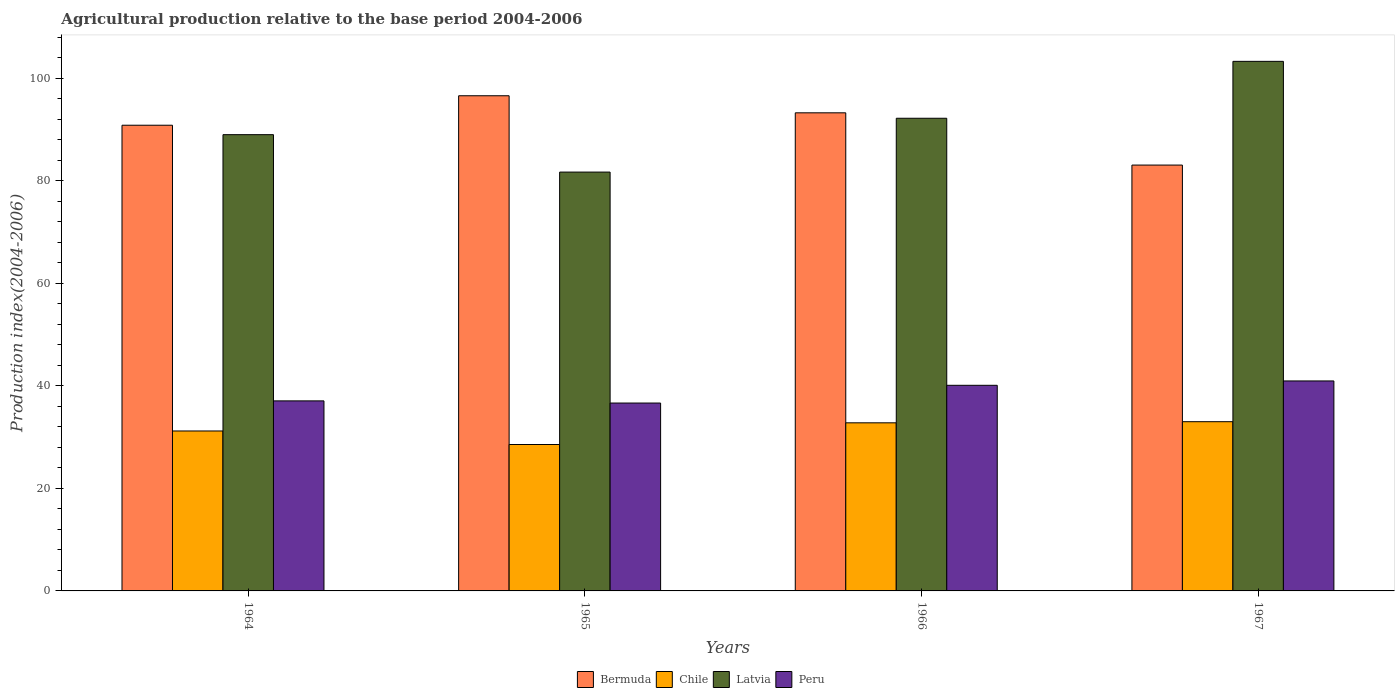How many different coloured bars are there?
Offer a very short reply. 4. How many groups of bars are there?
Make the answer very short. 4. Are the number of bars on each tick of the X-axis equal?
Provide a short and direct response. Yes. How many bars are there on the 1st tick from the right?
Keep it short and to the point. 4. What is the label of the 3rd group of bars from the left?
Make the answer very short. 1966. In how many cases, is the number of bars for a given year not equal to the number of legend labels?
Make the answer very short. 0. What is the agricultural production index in Chile in 1965?
Offer a very short reply. 28.56. Across all years, what is the maximum agricultural production index in Latvia?
Offer a terse response. 103.3. Across all years, what is the minimum agricultural production index in Chile?
Offer a very short reply. 28.56. In which year was the agricultural production index in Chile maximum?
Offer a terse response. 1967. In which year was the agricultural production index in Bermuda minimum?
Keep it short and to the point. 1967. What is the total agricultural production index in Bermuda in the graph?
Offer a very short reply. 363.76. What is the difference between the agricultural production index in Peru in 1965 and that in 1966?
Give a very brief answer. -3.46. What is the difference between the agricultural production index in Bermuda in 1964 and the agricultural production index in Latvia in 1967?
Provide a succinct answer. -12.46. What is the average agricultural production index in Chile per year?
Give a very brief answer. 31.39. In the year 1966, what is the difference between the agricultural production index in Chile and agricultural production index in Latvia?
Make the answer very short. -59.41. What is the ratio of the agricultural production index in Peru in 1964 to that in 1967?
Your answer should be compact. 0.91. What is the difference between the highest and the second highest agricultural production index in Latvia?
Offer a very short reply. 11.1. What is the difference between the highest and the lowest agricultural production index in Bermuda?
Give a very brief answer. 13.52. Is it the case that in every year, the sum of the agricultural production index in Peru and agricultural production index in Latvia is greater than the sum of agricultural production index in Bermuda and agricultural production index in Chile?
Give a very brief answer. No. What does the 2nd bar from the left in 1964 represents?
Provide a short and direct response. Chile. Is it the case that in every year, the sum of the agricultural production index in Bermuda and agricultural production index in Peru is greater than the agricultural production index in Latvia?
Offer a very short reply. Yes. How many bars are there?
Your answer should be compact. 16. Are all the bars in the graph horizontal?
Keep it short and to the point. No. How many years are there in the graph?
Ensure brevity in your answer.  4. Does the graph contain any zero values?
Offer a terse response. No. Does the graph contain grids?
Provide a succinct answer. No. Where does the legend appear in the graph?
Keep it short and to the point. Bottom center. How many legend labels are there?
Provide a short and direct response. 4. How are the legend labels stacked?
Your answer should be very brief. Horizontal. What is the title of the graph?
Offer a terse response. Agricultural production relative to the base period 2004-2006. What is the label or title of the Y-axis?
Provide a succinct answer. Production index(2004-2006). What is the Production index(2004-2006) in Bermuda in 1964?
Your response must be concise. 90.84. What is the Production index(2004-2006) in Chile in 1964?
Offer a very short reply. 31.2. What is the Production index(2004-2006) of Latvia in 1964?
Ensure brevity in your answer.  89. What is the Production index(2004-2006) of Peru in 1964?
Offer a terse response. 37.07. What is the Production index(2004-2006) of Bermuda in 1965?
Provide a succinct answer. 96.59. What is the Production index(2004-2006) of Chile in 1965?
Give a very brief answer. 28.56. What is the Production index(2004-2006) in Latvia in 1965?
Ensure brevity in your answer.  81.7. What is the Production index(2004-2006) of Peru in 1965?
Provide a short and direct response. 36.65. What is the Production index(2004-2006) in Bermuda in 1966?
Your answer should be compact. 93.26. What is the Production index(2004-2006) in Chile in 1966?
Your answer should be very brief. 32.79. What is the Production index(2004-2006) of Latvia in 1966?
Your answer should be very brief. 92.2. What is the Production index(2004-2006) of Peru in 1966?
Make the answer very short. 40.11. What is the Production index(2004-2006) of Bermuda in 1967?
Ensure brevity in your answer.  83.07. What is the Production index(2004-2006) of Chile in 1967?
Ensure brevity in your answer.  33.01. What is the Production index(2004-2006) of Latvia in 1967?
Offer a very short reply. 103.3. What is the Production index(2004-2006) in Peru in 1967?
Your answer should be very brief. 40.96. Across all years, what is the maximum Production index(2004-2006) of Bermuda?
Ensure brevity in your answer.  96.59. Across all years, what is the maximum Production index(2004-2006) in Chile?
Give a very brief answer. 33.01. Across all years, what is the maximum Production index(2004-2006) of Latvia?
Your answer should be compact. 103.3. Across all years, what is the maximum Production index(2004-2006) of Peru?
Provide a succinct answer. 40.96. Across all years, what is the minimum Production index(2004-2006) in Bermuda?
Make the answer very short. 83.07. Across all years, what is the minimum Production index(2004-2006) of Chile?
Keep it short and to the point. 28.56. Across all years, what is the minimum Production index(2004-2006) of Latvia?
Ensure brevity in your answer.  81.7. Across all years, what is the minimum Production index(2004-2006) in Peru?
Your answer should be compact. 36.65. What is the total Production index(2004-2006) in Bermuda in the graph?
Offer a terse response. 363.76. What is the total Production index(2004-2006) of Chile in the graph?
Your response must be concise. 125.56. What is the total Production index(2004-2006) in Latvia in the graph?
Your answer should be very brief. 366.2. What is the total Production index(2004-2006) in Peru in the graph?
Keep it short and to the point. 154.79. What is the difference between the Production index(2004-2006) in Bermuda in 1964 and that in 1965?
Your response must be concise. -5.75. What is the difference between the Production index(2004-2006) of Chile in 1964 and that in 1965?
Your response must be concise. 2.64. What is the difference between the Production index(2004-2006) of Peru in 1964 and that in 1965?
Provide a succinct answer. 0.42. What is the difference between the Production index(2004-2006) in Bermuda in 1964 and that in 1966?
Your response must be concise. -2.42. What is the difference between the Production index(2004-2006) of Chile in 1964 and that in 1966?
Ensure brevity in your answer.  -1.59. What is the difference between the Production index(2004-2006) in Latvia in 1964 and that in 1966?
Provide a short and direct response. -3.2. What is the difference between the Production index(2004-2006) in Peru in 1964 and that in 1966?
Ensure brevity in your answer.  -3.04. What is the difference between the Production index(2004-2006) in Bermuda in 1964 and that in 1967?
Provide a succinct answer. 7.77. What is the difference between the Production index(2004-2006) in Chile in 1964 and that in 1967?
Keep it short and to the point. -1.81. What is the difference between the Production index(2004-2006) in Latvia in 1964 and that in 1967?
Provide a succinct answer. -14.3. What is the difference between the Production index(2004-2006) in Peru in 1964 and that in 1967?
Keep it short and to the point. -3.89. What is the difference between the Production index(2004-2006) in Bermuda in 1965 and that in 1966?
Provide a short and direct response. 3.33. What is the difference between the Production index(2004-2006) of Chile in 1965 and that in 1966?
Your answer should be very brief. -4.23. What is the difference between the Production index(2004-2006) in Peru in 1965 and that in 1966?
Ensure brevity in your answer.  -3.46. What is the difference between the Production index(2004-2006) in Bermuda in 1965 and that in 1967?
Give a very brief answer. 13.52. What is the difference between the Production index(2004-2006) in Chile in 1965 and that in 1967?
Keep it short and to the point. -4.45. What is the difference between the Production index(2004-2006) in Latvia in 1965 and that in 1967?
Give a very brief answer. -21.6. What is the difference between the Production index(2004-2006) in Peru in 1965 and that in 1967?
Ensure brevity in your answer.  -4.31. What is the difference between the Production index(2004-2006) in Bermuda in 1966 and that in 1967?
Keep it short and to the point. 10.19. What is the difference between the Production index(2004-2006) of Chile in 1966 and that in 1967?
Your answer should be compact. -0.22. What is the difference between the Production index(2004-2006) in Latvia in 1966 and that in 1967?
Make the answer very short. -11.1. What is the difference between the Production index(2004-2006) of Peru in 1966 and that in 1967?
Provide a short and direct response. -0.85. What is the difference between the Production index(2004-2006) of Bermuda in 1964 and the Production index(2004-2006) of Chile in 1965?
Keep it short and to the point. 62.28. What is the difference between the Production index(2004-2006) in Bermuda in 1964 and the Production index(2004-2006) in Latvia in 1965?
Offer a terse response. 9.14. What is the difference between the Production index(2004-2006) of Bermuda in 1964 and the Production index(2004-2006) of Peru in 1965?
Your answer should be very brief. 54.19. What is the difference between the Production index(2004-2006) in Chile in 1964 and the Production index(2004-2006) in Latvia in 1965?
Ensure brevity in your answer.  -50.5. What is the difference between the Production index(2004-2006) in Chile in 1964 and the Production index(2004-2006) in Peru in 1965?
Make the answer very short. -5.45. What is the difference between the Production index(2004-2006) in Latvia in 1964 and the Production index(2004-2006) in Peru in 1965?
Your answer should be very brief. 52.35. What is the difference between the Production index(2004-2006) in Bermuda in 1964 and the Production index(2004-2006) in Chile in 1966?
Your answer should be very brief. 58.05. What is the difference between the Production index(2004-2006) of Bermuda in 1964 and the Production index(2004-2006) of Latvia in 1966?
Your response must be concise. -1.36. What is the difference between the Production index(2004-2006) in Bermuda in 1964 and the Production index(2004-2006) in Peru in 1966?
Offer a terse response. 50.73. What is the difference between the Production index(2004-2006) of Chile in 1964 and the Production index(2004-2006) of Latvia in 1966?
Provide a succinct answer. -61. What is the difference between the Production index(2004-2006) of Chile in 1964 and the Production index(2004-2006) of Peru in 1966?
Provide a succinct answer. -8.91. What is the difference between the Production index(2004-2006) of Latvia in 1964 and the Production index(2004-2006) of Peru in 1966?
Provide a succinct answer. 48.89. What is the difference between the Production index(2004-2006) of Bermuda in 1964 and the Production index(2004-2006) of Chile in 1967?
Your response must be concise. 57.83. What is the difference between the Production index(2004-2006) of Bermuda in 1964 and the Production index(2004-2006) of Latvia in 1967?
Give a very brief answer. -12.46. What is the difference between the Production index(2004-2006) of Bermuda in 1964 and the Production index(2004-2006) of Peru in 1967?
Give a very brief answer. 49.88. What is the difference between the Production index(2004-2006) in Chile in 1964 and the Production index(2004-2006) in Latvia in 1967?
Your response must be concise. -72.1. What is the difference between the Production index(2004-2006) of Chile in 1964 and the Production index(2004-2006) of Peru in 1967?
Provide a succinct answer. -9.76. What is the difference between the Production index(2004-2006) of Latvia in 1964 and the Production index(2004-2006) of Peru in 1967?
Provide a succinct answer. 48.04. What is the difference between the Production index(2004-2006) in Bermuda in 1965 and the Production index(2004-2006) in Chile in 1966?
Keep it short and to the point. 63.8. What is the difference between the Production index(2004-2006) of Bermuda in 1965 and the Production index(2004-2006) of Latvia in 1966?
Give a very brief answer. 4.39. What is the difference between the Production index(2004-2006) of Bermuda in 1965 and the Production index(2004-2006) of Peru in 1966?
Make the answer very short. 56.48. What is the difference between the Production index(2004-2006) in Chile in 1965 and the Production index(2004-2006) in Latvia in 1966?
Give a very brief answer. -63.64. What is the difference between the Production index(2004-2006) of Chile in 1965 and the Production index(2004-2006) of Peru in 1966?
Your answer should be compact. -11.55. What is the difference between the Production index(2004-2006) in Latvia in 1965 and the Production index(2004-2006) in Peru in 1966?
Your answer should be compact. 41.59. What is the difference between the Production index(2004-2006) in Bermuda in 1965 and the Production index(2004-2006) in Chile in 1967?
Ensure brevity in your answer.  63.58. What is the difference between the Production index(2004-2006) in Bermuda in 1965 and the Production index(2004-2006) in Latvia in 1967?
Make the answer very short. -6.71. What is the difference between the Production index(2004-2006) of Bermuda in 1965 and the Production index(2004-2006) of Peru in 1967?
Offer a very short reply. 55.63. What is the difference between the Production index(2004-2006) of Chile in 1965 and the Production index(2004-2006) of Latvia in 1967?
Offer a terse response. -74.74. What is the difference between the Production index(2004-2006) of Chile in 1965 and the Production index(2004-2006) of Peru in 1967?
Keep it short and to the point. -12.4. What is the difference between the Production index(2004-2006) of Latvia in 1965 and the Production index(2004-2006) of Peru in 1967?
Your answer should be very brief. 40.74. What is the difference between the Production index(2004-2006) of Bermuda in 1966 and the Production index(2004-2006) of Chile in 1967?
Give a very brief answer. 60.25. What is the difference between the Production index(2004-2006) in Bermuda in 1966 and the Production index(2004-2006) in Latvia in 1967?
Provide a succinct answer. -10.04. What is the difference between the Production index(2004-2006) in Bermuda in 1966 and the Production index(2004-2006) in Peru in 1967?
Provide a short and direct response. 52.3. What is the difference between the Production index(2004-2006) in Chile in 1966 and the Production index(2004-2006) in Latvia in 1967?
Provide a succinct answer. -70.51. What is the difference between the Production index(2004-2006) in Chile in 1966 and the Production index(2004-2006) in Peru in 1967?
Your answer should be compact. -8.17. What is the difference between the Production index(2004-2006) in Latvia in 1966 and the Production index(2004-2006) in Peru in 1967?
Your answer should be very brief. 51.24. What is the average Production index(2004-2006) in Bermuda per year?
Your answer should be compact. 90.94. What is the average Production index(2004-2006) in Chile per year?
Ensure brevity in your answer.  31.39. What is the average Production index(2004-2006) of Latvia per year?
Provide a succinct answer. 91.55. What is the average Production index(2004-2006) of Peru per year?
Your response must be concise. 38.7. In the year 1964, what is the difference between the Production index(2004-2006) in Bermuda and Production index(2004-2006) in Chile?
Your answer should be compact. 59.64. In the year 1964, what is the difference between the Production index(2004-2006) of Bermuda and Production index(2004-2006) of Latvia?
Make the answer very short. 1.84. In the year 1964, what is the difference between the Production index(2004-2006) in Bermuda and Production index(2004-2006) in Peru?
Make the answer very short. 53.77. In the year 1964, what is the difference between the Production index(2004-2006) in Chile and Production index(2004-2006) in Latvia?
Make the answer very short. -57.8. In the year 1964, what is the difference between the Production index(2004-2006) of Chile and Production index(2004-2006) of Peru?
Ensure brevity in your answer.  -5.87. In the year 1964, what is the difference between the Production index(2004-2006) in Latvia and Production index(2004-2006) in Peru?
Make the answer very short. 51.93. In the year 1965, what is the difference between the Production index(2004-2006) of Bermuda and Production index(2004-2006) of Chile?
Offer a terse response. 68.03. In the year 1965, what is the difference between the Production index(2004-2006) in Bermuda and Production index(2004-2006) in Latvia?
Make the answer very short. 14.89. In the year 1965, what is the difference between the Production index(2004-2006) in Bermuda and Production index(2004-2006) in Peru?
Give a very brief answer. 59.94. In the year 1965, what is the difference between the Production index(2004-2006) in Chile and Production index(2004-2006) in Latvia?
Give a very brief answer. -53.14. In the year 1965, what is the difference between the Production index(2004-2006) in Chile and Production index(2004-2006) in Peru?
Your answer should be very brief. -8.09. In the year 1965, what is the difference between the Production index(2004-2006) in Latvia and Production index(2004-2006) in Peru?
Offer a very short reply. 45.05. In the year 1966, what is the difference between the Production index(2004-2006) in Bermuda and Production index(2004-2006) in Chile?
Offer a very short reply. 60.47. In the year 1966, what is the difference between the Production index(2004-2006) in Bermuda and Production index(2004-2006) in Latvia?
Keep it short and to the point. 1.06. In the year 1966, what is the difference between the Production index(2004-2006) of Bermuda and Production index(2004-2006) of Peru?
Offer a terse response. 53.15. In the year 1966, what is the difference between the Production index(2004-2006) in Chile and Production index(2004-2006) in Latvia?
Offer a terse response. -59.41. In the year 1966, what is the difference between the Production index(2004-2006) of Chile and Production index(2004-2006) of Peru?
Your answer should be compact. -7.32. In the year 1966, what is the difference between the Production index(2004-2006) of Latvia and Production index(2004-2006) of Peru?
Give a very brief answer. 52.09. In the year 1967, what is the difference between the Production index(2004-2006) in Bermuda and Production index(2004-2006) in Chile?
Provide a succinct answer. 50.06. In the year 1967, what is the difference between the Production index(2004-2006) in Bermuda and Production index(2004-2006) in Latvia?
Your answer should be very brief. -20.23. In the year 1967, what is the difference between the Production index(2004-2006) of Bermuda and Production index(2004-2006) of Peru?
Make the answer very short. 42.11. In the year 1967, what is the difference between the Production index(2004-2006) of Chile and Production index(2004-2006) of Latvia?
Ensure brevity in your answer.  -70.29. In the year 1967, what is the difference between the Production index(2004-2006) of Chile and Production index(2004-2006) of Peru?
Your answer should be compact. -7.95. In the year 1967, what is the difference between the Production index(2004-2006) in Latvia and Production index(2004-2006) in Peru?
Ensure brevity in your answer.  62.34. What is the ratio of the Production index(2004-2006) in Bermuda in 1964 to that in 1965?
Your answer should be very brief. 0.94. What is the ratio of the Production index(2004-2006) of Chile in 1964 to that in 1965?
Provide a short and direct response. 1.09. What is the ratio of the Production index(2004-2006) in Latvia in 1964 to that in 1965?
Provide a short and direct response. 1.09. What is the ratio of the Production index(2004-2006) in Peru in 1964 to that in 1965?
Your answer should be compact. 1.01. What is the ratio of the Production index(2004-2006) in Bermuda in 1964 to that in 1966?
Ensure brevity in your answer.  0.97. What is the ratio of the Production index(2004-2006) of Chile in 1964 to that in 1966?
Offer a very short reply. 0.95. What is the ratio of the Production index(2004-2006) of Latvia in 1964 to that in 1966?
Offer a terse response. 0.97. What is the ratio of the Production index(2004-2006) of Peru in 1964 to that in 1966?
Make the answer very short. 0.92. What is the ratio of the Production index(2004-2006) of Bermuda in 1964 to that in 1967?
Ensure brevity in your answer.  1.09. What is the ratio of the Production index(2004-2006) in Chile in 1964 to that in 1967?
Your answer should be compact. 0.95. What is the ratio of the Production index(2004-2006) in Latvia in 1964 to that in 1967?
Your answer should be compact. 0.86. What is the ratio of the Production index(2004-2006) of Peru in 1964 to that in 1967?
Offer a very short reply. 0.91. What is the ratio of the Production index(2004-2006) of Bermuda in 1965 to that in 1966?
Your answer should be very brief. 1.04. What is the ratio of the Production index(2004-2006) of Chile in 1965 to that in 1966?
Make the answer very short. 0.87. What is the ratio of the Production index(2004-2006) in Latvia in 1965 to that in 1966?
Make the answer very short. 0.89. What is the ratio of the Production index(2004-2006) in Peru in 1965 to that in 1966?
Provide a succinct answer. 0.91. What is the ratio of the Production index(2004-2006) in Bermuda in 1965 to that in 1967?
Offer a very short reply. 1.16. What is the ratio of the Production index(2004-2006) in Chile in 1965 to that in 1967?
Your answer should be compact. 0.87. What is the ratio of the Production index(2004-2006) in Latvia in 1965 to that in 1967?
Keep it short and to the point. 0.79. What is the ratio of the Production index(2004-2006) in Peru in 1965 to that in 1967?
Make the answer very short. 0.89. What is the ratio of the Production index(2004-2006) of Bermuda in 1966 to that in 1967?
Give a very brief answer. 1.12. What is the ratio of the Production index(2004-2006) in Chile in 1966 to that in 1967?
Ensure brevity in your answer.  0.99. What is the ratio of the Production index(2004-2006) in Latvia in 1966 to that in 1967?
Provide a succinct answer. 0.89. What is the ratio of the Production index(2004-2006) of Peru in 1966 to that in 1967?
Provide a succinct answer. 0.98. What is the difference between the highest and the second highest Production index(2004-2006) in Bermuda?
Give a very brief answer. 3.33. What is the difference between the highest and the second highest Production index(2004-2006) in Chile?
Provide a short and direct response. 0.22. What is the difference between the highest and the second highest Production index(2004-2006) of Peru?
Provide a succinct answer. 0.85. What is the difference between the highest and the lowest Production index(2004-2006) of Bermuda?
Keep it short and to the point. 13.52. What is the difference between the highest and the lowest Production index(2004-2006) of Chile?
Provide a succinct answer. 4.45. What is the difference between the highest and the lowest Production index(2004-2006) of Latvia?
Offer a terse response. 21.6. What is the difference between the highest and the lowest Production index(2004-2006) of Peru?
Keep it short and to the point. 4.31. 